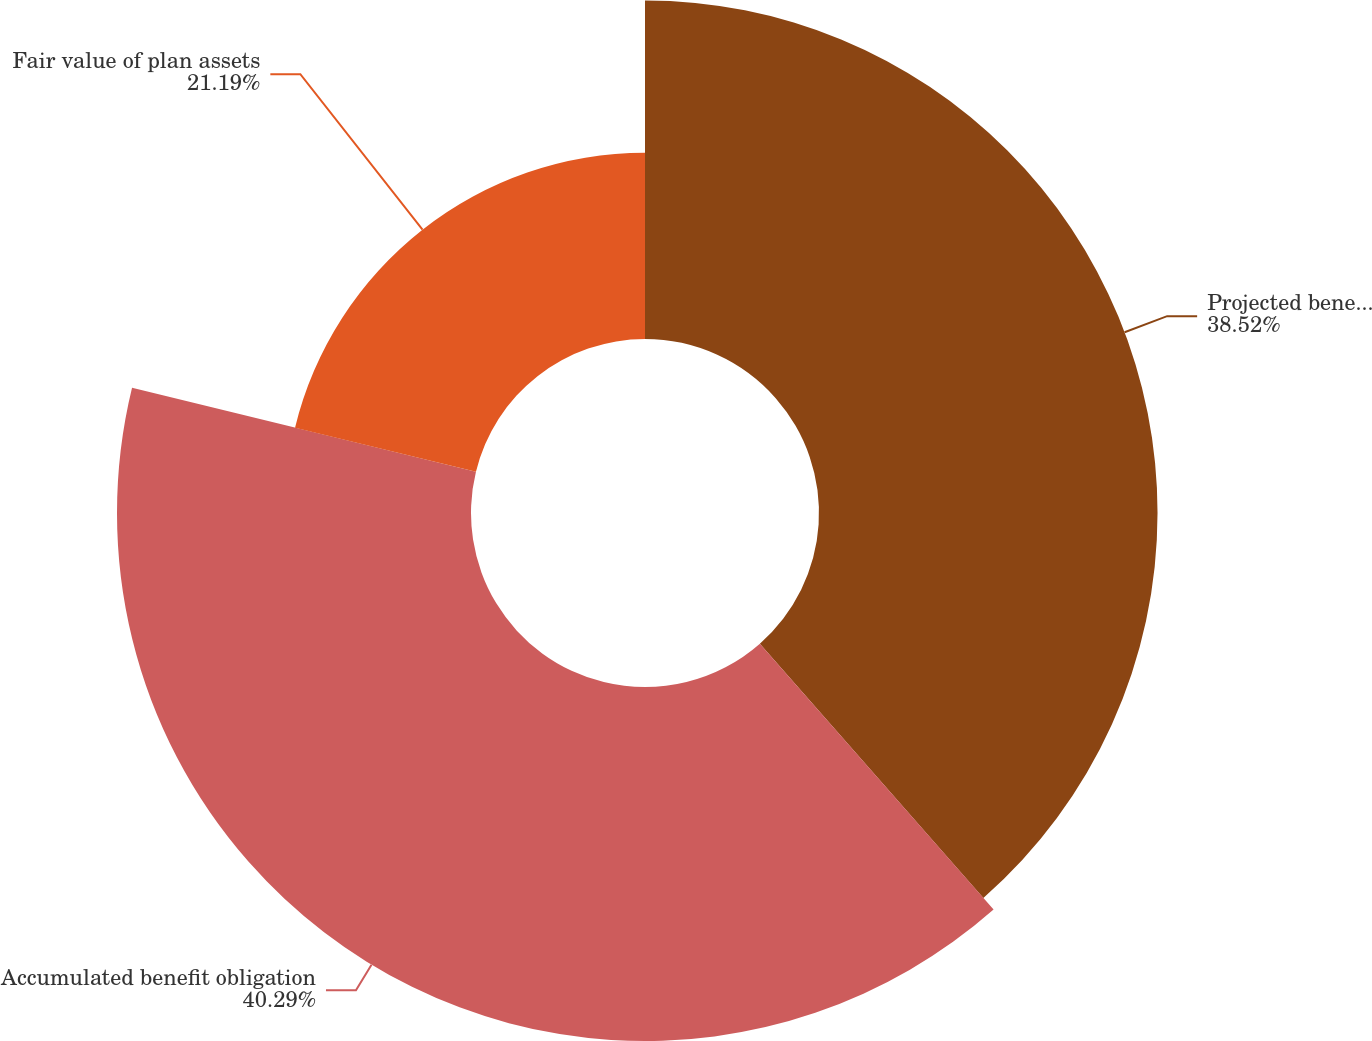Convert chart to OTSL. <chart><loc_0><loc_0><loc_500><loc_500><pie_chart><fcel>Projected benefit obligation<fcel>Accumulated benefit obligation<fcel>Fair value of plan assets<nl><fcel>38.52%<fcel>40.28%<fcel>21.19%<nl></chart> 